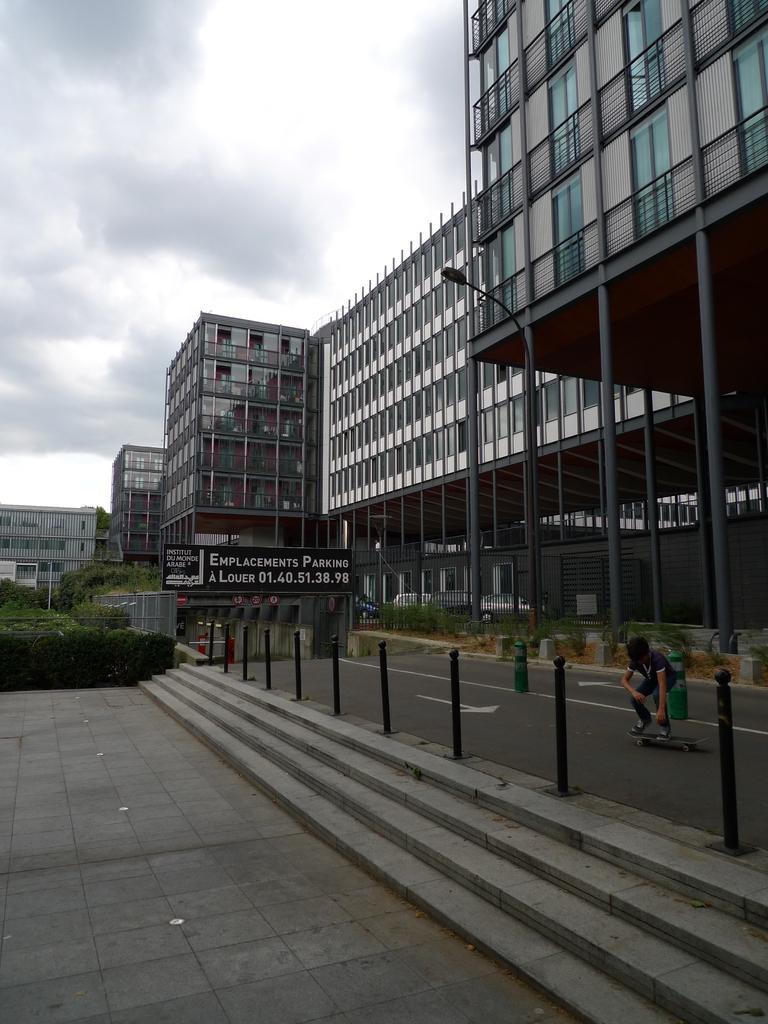How would you summarize this image in a sentence or two? In the foreground of this image, there are stairs, pavement, bollards, road and a man skating on the road. In the background, there are glass buildings, greenery, a board and sky and the cloud at the top. 